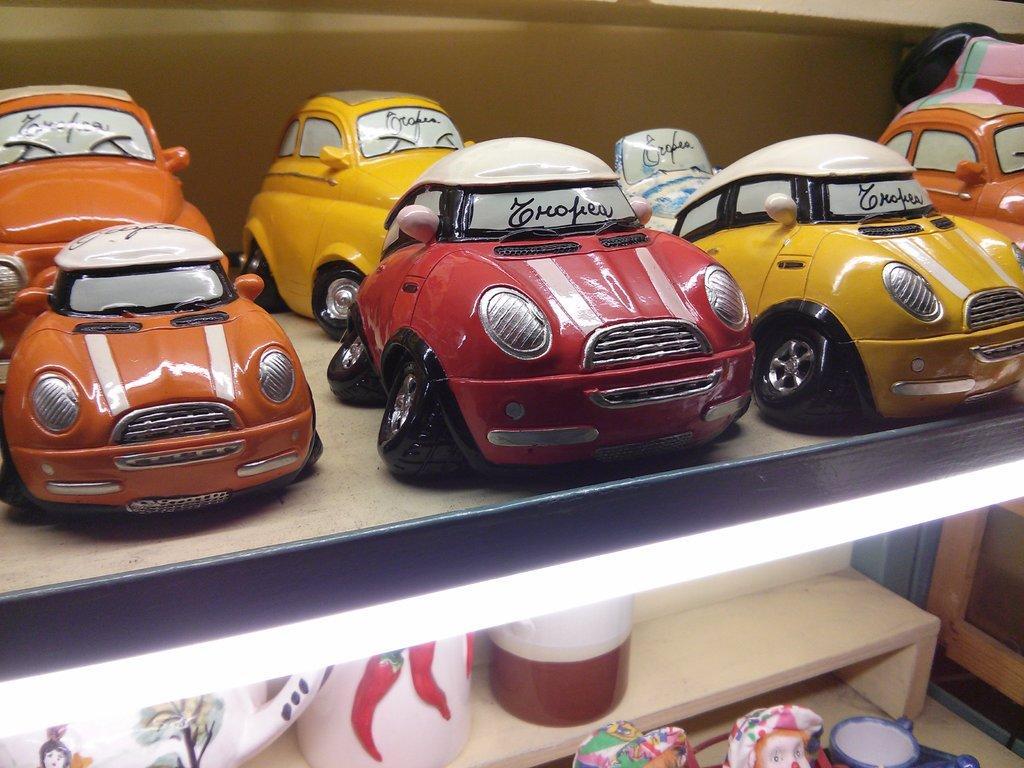Please provide a concise description of this image. In this image there are some shelves and in the shelves there are some toy cars, and at the bottom of the image there are some pots and cups. And on the right side of the image there is one wooden boards, and in the background it looks like a wall. 